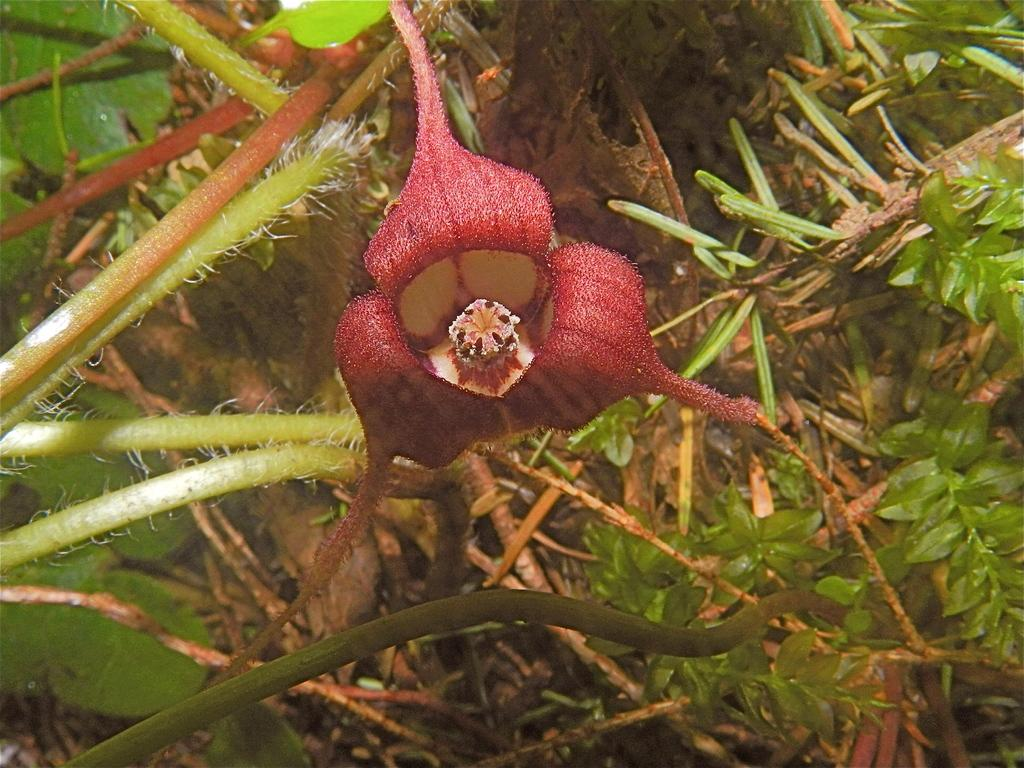What type of plant is in the image? There is a western wild ginger plant in the image. What are the main parts of the plant that can be seen in the image? The plant has a stem and leaves. What type of circle can be seen surrounding the plant in the image? There is no circle surrounding the plant in the image. Is there a baseball game happening in the image? There is no reference to a baseball game or any sports activity in the image. 